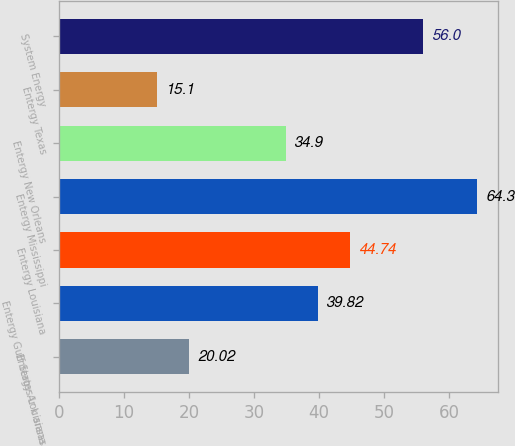Convert chart to OTSL. <chart><loc_0><loc_0><loc_500><loc_500><bar_chart><fcel>Entergy Ar k ansas<fcel>Entergy Gulf States Louisiana<fcel>Entergy Louisiana<fcel>Entergy Mississippi<fcel>Entergy New Orleans<fcel>Entergy Texas<fcel>System Energy<nl><fcel>20.02<fcel>39.82<fcel>44.74<fcel>64.3<fcel>34.9<fcel>15.1<fcel>56<nl></chart> 